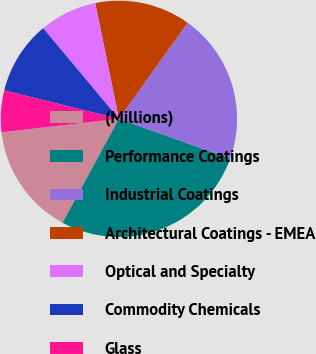Convert chart to OTSL. <chart><loc_0><loc_0><loc_500><loc_500><pie_chart><fcel>(Millions)<fcel>Performance Coatings<fcel>Industrial Coatings<fcel>Architectural Coatings - EMEA<fcel>Optical and Specialty<fcel>Commodity Chemicals<fcel>Glass<nl><fcel>15.27%<fcel>27.46%<fcel>20.57%<fcel>13.09%<fcel>7.87%<fcel>10.05%<fcel>5.69%<nl></chart> 